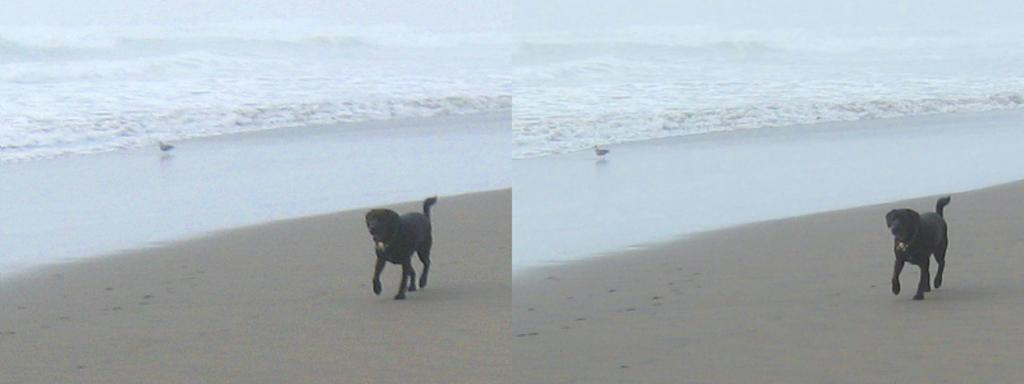What type of artwork is the image? The image is a collage. What is happening in the scene involving the dog? The dog is running on the sand. What natural element is visible in the image? There is water visible in the image. What is the bird doing in the image? The bird is standing at the water. What time does the clock show in the image? There is no clock present in the image. How many beans are visible in the image? There are no beans visible in the image. 